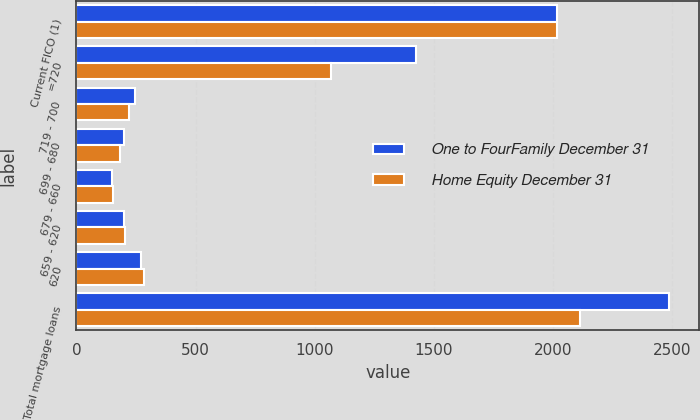Convert chart. <chart><loc_0><loc_0><loc_500><loc_500><stacked_bar_chart><ecel><fcel>Current FICO (1)<fcel>=720<fcel>719 - 700<fcel>699 - 680<fcel>679 - 660<fcel>659 - 620<fcel>620<fcel>Total mortgage loans<nl><fcel>One to FourFamily December 31<fcel>2015<fcel>1423<fcel>246<fcel>198<fcel>150<fcel>198<fcel>273<fcel>2488<nl><fcel>Home Equity December 31<fcel>2015<fcel>1069<fcel>222<fcel>183<fcel>152<fcel>203<fcel>285<fcel>2114<nl></chart> 